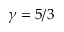Convert formula to latex. <formula><loc_0><loc_0><loc_500><loc_500>\gamma = 5 / 3</formula> 